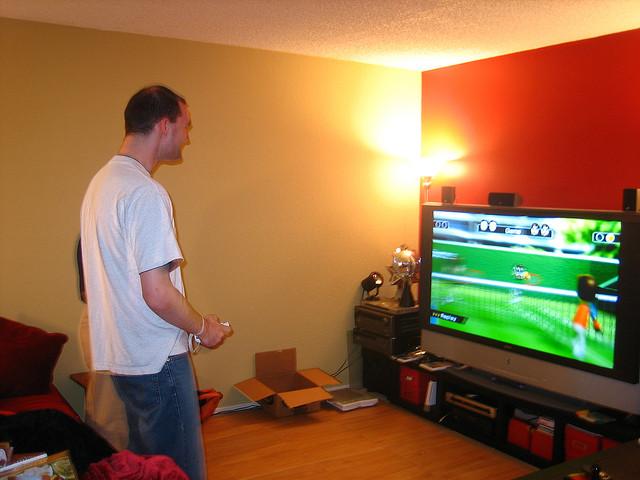What are they watching on TV?
Concise answer only. Wii. What is the team logo on the TV?
Write a very short answer. Wii. What  type of game console is being used?
Quick response, please. Wii. Is this a flat screen television?
Give a very brief answer. Yes. What color is the man's shirt?
Concise answer only. White. How many lights are on the ceiling?
Be succinct. 0. How many people in the room?
Be succinct. 2. 